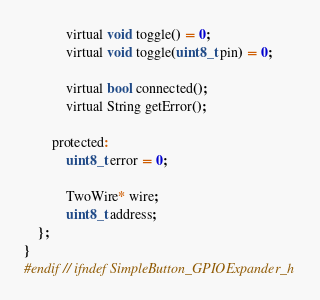Convert code to text. <code><loc_0><loc_0><loc_500><loc_500><_C_>
            virtual void toggle() = 0;
            virtual void toggle(uint8_t pin) = 0;

            virtual bool connected();
            virtual String getError();

        protected:
            uint8_t error = 0;

            TwoWire* wire;
            uint8_t address;
    };
}
#endif // ifndef SimpleButton_GPIOExpander_h</code> 